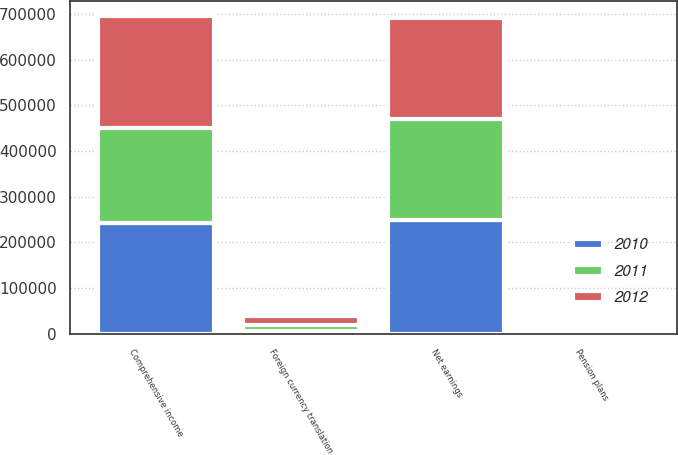Convert chart to OTSL. <chart><loc_0><loc_0><loc_500><loc_500><stacked_bar_chart><ecel><fcel>Net earnings<fcel>Pension plans<fcel>Foreign currency translation<fcel>Comprehensive income<nl><fcel>2012<fcel>222398<fcel>745<fcel>20790<fcel>243933<nl><fcel>2011<fcel>221474<fcel>1113<fcel>12533<fcel>207828<nl><fcel>2010<fcel>248126<fcel>664<fcel>6142<fcel>242648<nl></chart> 